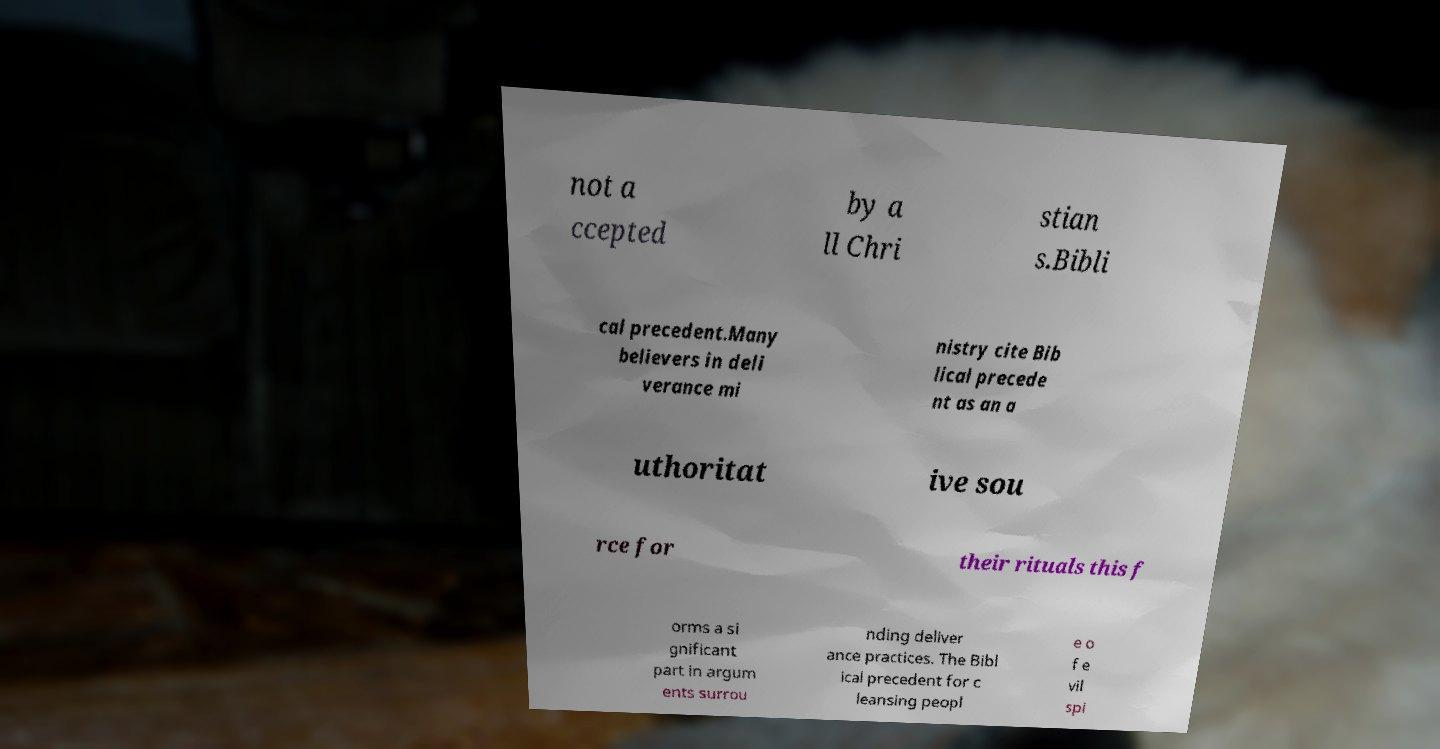There's text embedded in this image that I need extracted. Can you transcribe it verbatim? not a ccepted by a ll Chri stian s.Bibli cal precedent.Many believers in deli verance mi nistry cite Bib lical precede nt as an a uthoritat ive sou rce for their rituals this f orms a si gnificant part in argum ents surrou nding deliver ance practices. The Bibl ical precedent for c leansing peopl e o f e vil spi 